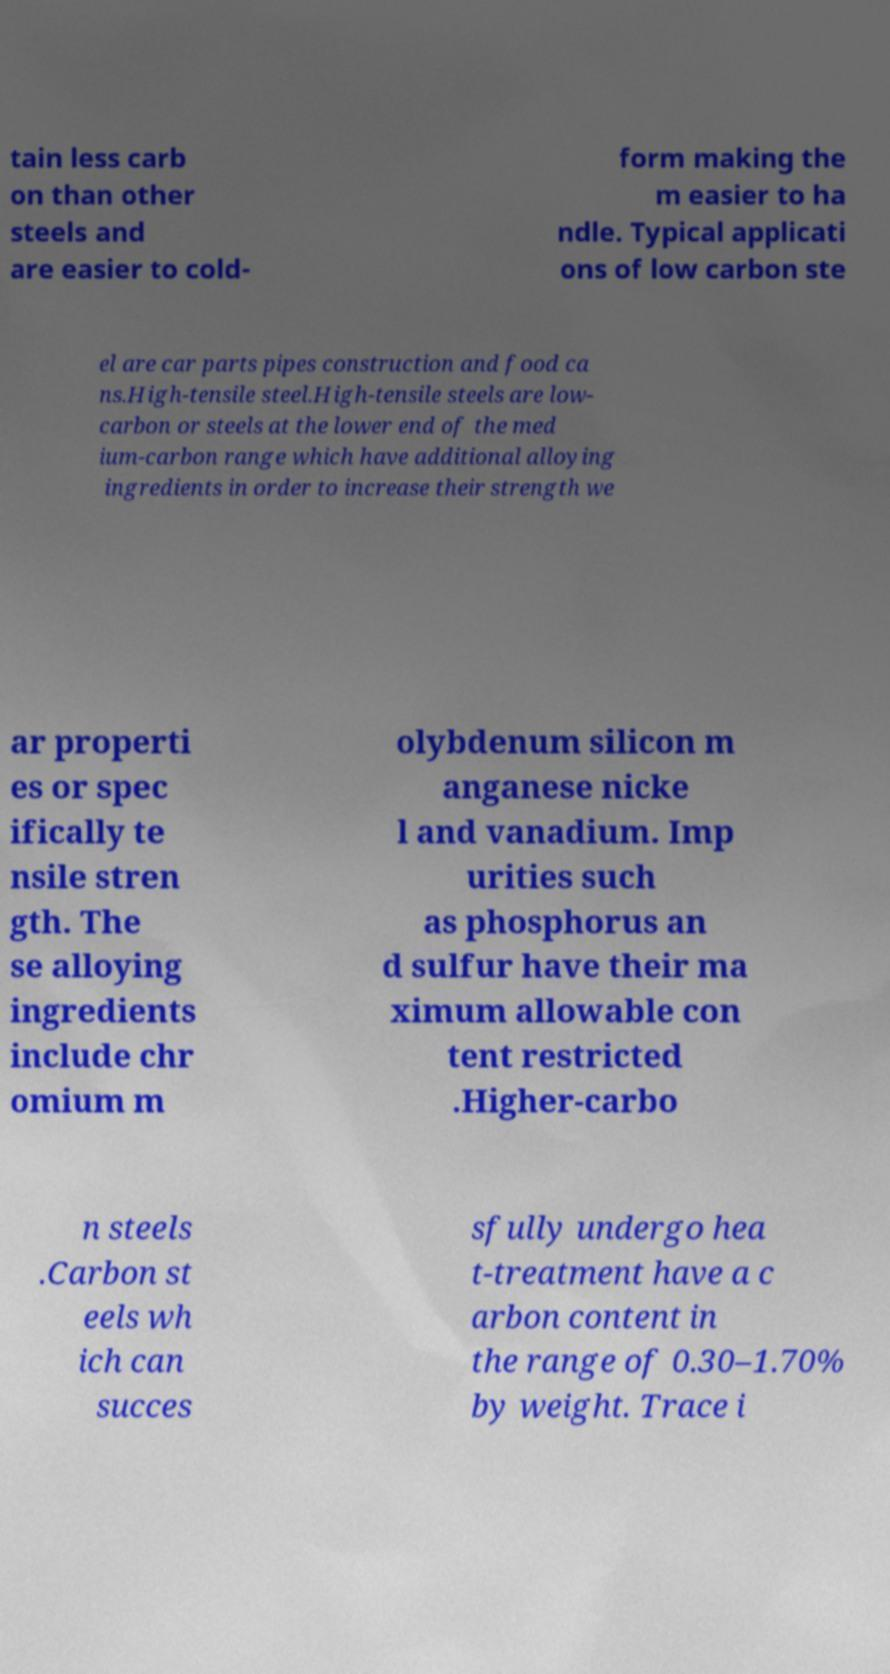Please read and relay the text visible in this image. What does it say? tain less carb on than other steels and are easier to cold- form making the m easier to ha ndle. Typical applicati ons of low carbon ste el are car parts pipes construction and food ca ns.High-tensile steel.High-tensile steels are low- carbon or steels at the lower end of the med ium-carbon range which have additional alloying ingredients in order to increase their strength we ar properti es or spec ifically te nsile stren gth. The se alloying ingredients include chr omium m olybdenum silicon m anganese nicke l and vanadium. Imp urities such as phosphorus an d sulfur have their ma ximum allowable con tent restricted .Higher-carbo n steels .Carbon st eels wh ich can succes sfully undergo hea t-treatment have a c arbon content in the range of 0.30–1.70% by weight. Trace i 